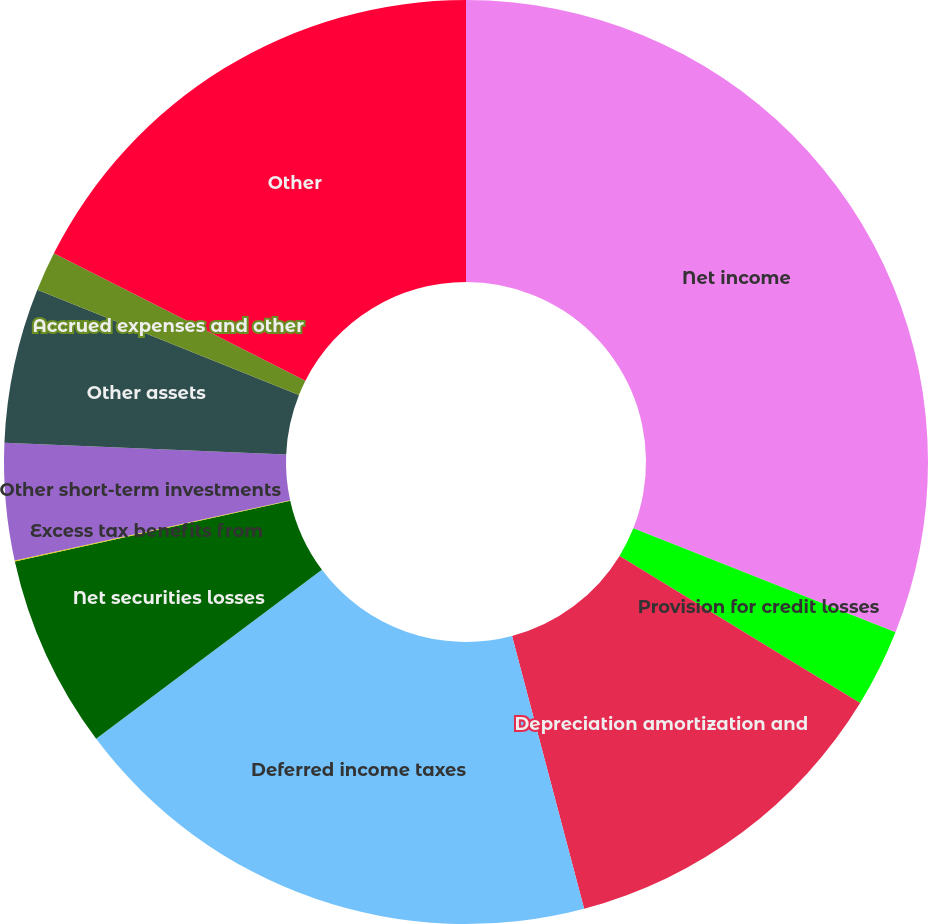<chart> <loc_0><loc_0><loc_500><loc_500><pie_chart><fcel>Net income<fcel>Provision for credit losses<fcel>Depreciation amortization and<fcel>Deferred income taxes<fcel>Net securities losses<fcel>Excess tax benefits from<fcel>Other short-term investments<fcel>Other assets<fcel>Accrued expenses and other<fcel>Other<nl><fcel>31.01%<fcel>2.73%<fcel>12.15%<fcel>18.89%<fcel>6.77%<fcel>0.04%<fcel>4.08%<fcel>5.42%<fcel>1.38%<fcel>17.54%<nl></chart> 